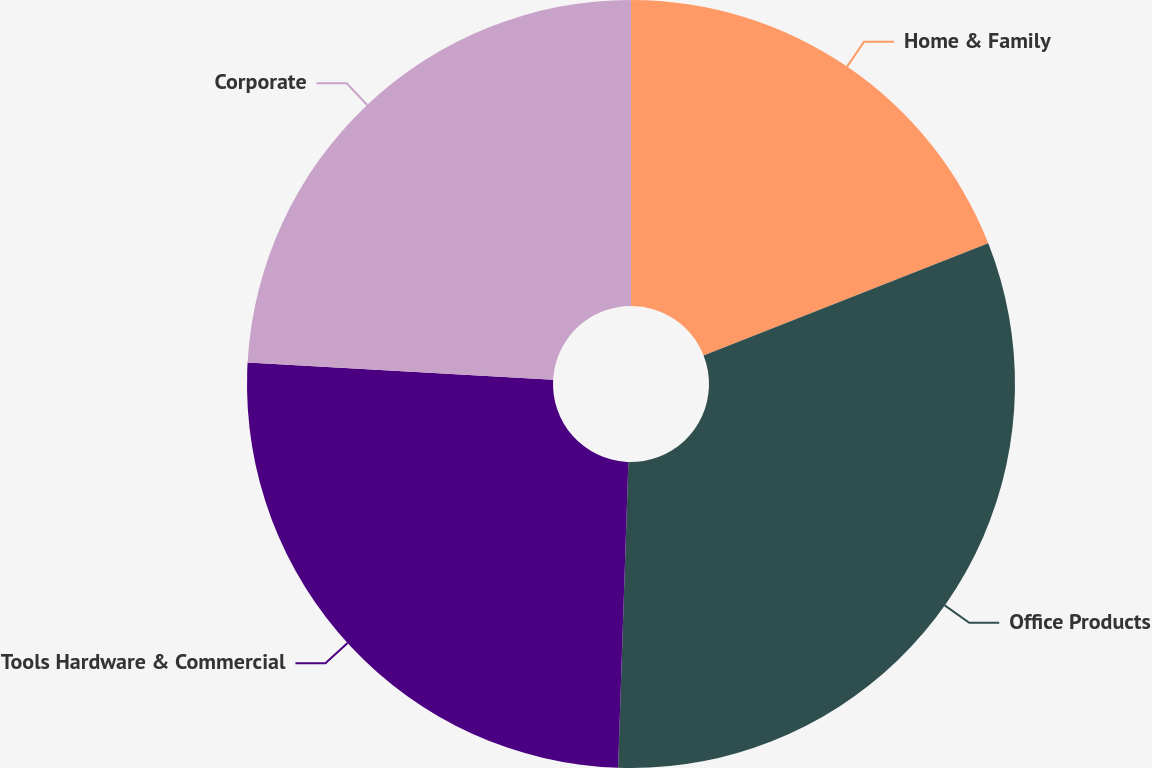Convert chart. <chart><loc_0><loc_0><loc_500><loc_500><pie_chart><fcel>Home & Family<fcel>Office Products<fcel>Tools Hardware & Commercial<fcel>Corporate<nl><fcel>19.03%<fcel>31.51%<fcel>25.36%<fcel>24.11%<nl></chart> 